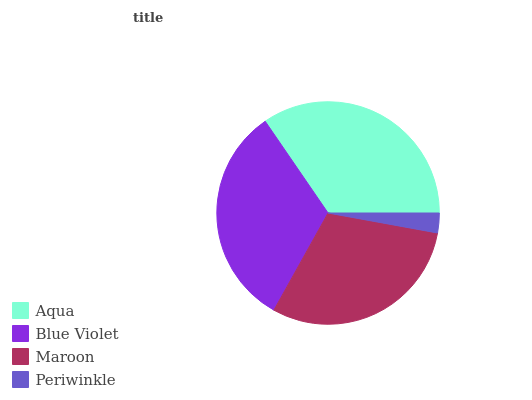Is Periwinkle the minimum?
Answer yes or no. Yes. Is Aqua the maximum?
Answer yes or no. Yes. Is Blue Violet the minimum?
Answer yes or no. No. Is Blue Violet the maximum?
Answer yes or no. No. Is Aqua greater than Blue Violet?
Answer yes or no. Yes. Is Blue Violet less than Aqua?
Answer yes or no. Yes. Is Blue Violet greater than Aqua?
Answer yes or no. No. Is Aqua less than Blue Violet?
Answer yes or no. No. Is Blue Violet the high median?
Answer yes or no. Yes. Is Maroon the low median?
Answer yes or no. Yes. Is Maroon the high median?
Answer yes or no. No. Is Blue Violet the low median?
Answer yes or no. No. 